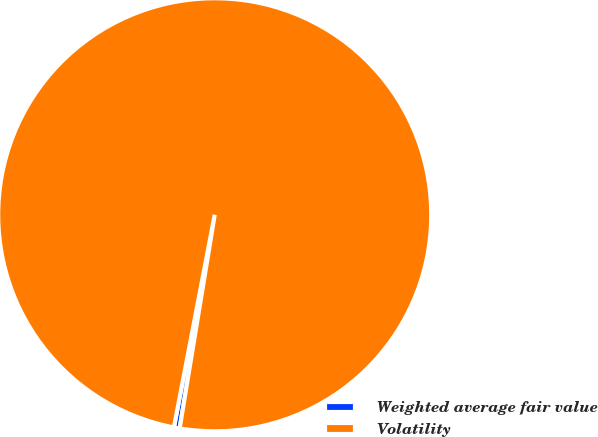Convert chart to OTSL. <chart><loc_0><loc_0><loc_500><loc_500><pie_chart><fcel>Weighted average fair value<fcel>Volatility<nl><fcel>0.43%<fcel>99.57%<nl></chart> 